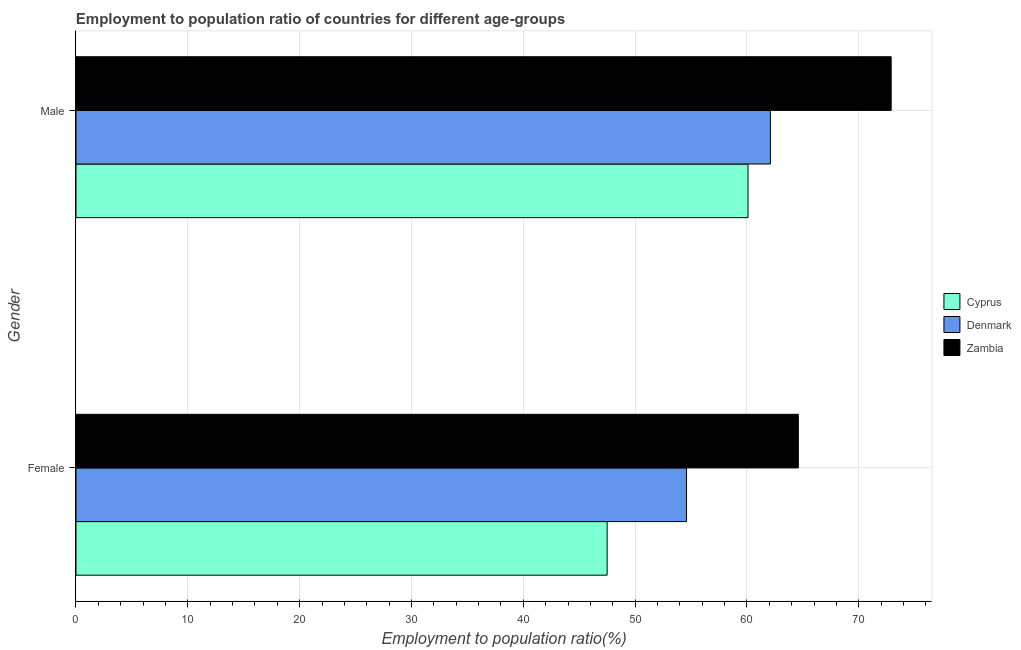How many groups of bars are there?
Provide a succinct answer. 2. How many bars are there on the 2nd tick from the bottom?
Ensure brevity in your answer.  3. What is the employment to population ratio(female) in Zambia?
Make the answer very short. 64.6. Across all countries, what is the maximum employment to population ratio(male)?
Keep it short and to the point. 72.9. Across all countries, what is the minimum employment to population ratio(female)?
Your answer should be very brief. 47.5. In which country was the employment to population ratio(female) maximum?
Give a very brief answer. Zambia. In which country was the employment to population ratio(female) minimum?
Ensure brevity in your answer.  Cyprus. What is the total employment to population ratio(female) in the graph?
Offer a very short reply. 166.7. What is the difference between the employment to population ratio(female) in Zambia and that in Cyprus?
Make the answer very short. 17.1. What is the difference between the employment to population ratio(female) in Cyprus and the employment to population ratio(male) in Denmark?
Provide a succinct answer. -14.6. What is the average employment to population ratio(male) per country?
Give a very brief answer. 65.03. What is the difference between the employment to population ratio(male) and employment to population ratio(female) in Zambia?
Provide a short and direct response. 8.3. In how many countries, is the employment to population ratio(male) greater than 74 %?
Offer a very short reply. 0. What is the ratio of the employment to population ratio(female) in Zambia to that in Denmark?
Your answer should be very brief. 1.18. In how many countries, is the employment to population ratio(female) greater than the average employment to population ratio(female) taken over all countries?
Your answer should be compact. 1. What does the 3rd bar from the top in Male represents?
Your response must be concise. Cyprus. What does the 3rd bar from the bottom in Male represents?
Make the answer very short. Zambia. How many bars are there?
Your answer should be compact. 6. Are all the bars in the graph horizontal?
Provide a short and direct response. Yes. How many countries are there in the graph?
Ensure brevity in your answer.  3. What is the difference between two consecutive major ticks on the X-axis?
Keep it short and to the point. 10. Are the values on the major ticks of X-axis written in scientific E-notation?
Your answer should be compact. No. Does the graph contain grids?
Provide a succinct answer. Yes. How are the legend labels stacked?
Make the answer very short. Vertical. What is the title of the graph?
Ensure brevity in your answer.  Employment to population ratio of countries for different age-groups. What is the label or title of the X-axis?
Provide a succinct answer. Employment to population ratio(%). What is the label or title of the Y-axis?
Offer a terse response. Gender. What is the Employment to population ratio(%) in Cyprus in Female?
Offer a very short reply. 47.5. What is the Employment to population ratio(%) in Denmark in Female?
Your response must be concise. 54.6. What is the Employment to population ratio(%) of Zambia in Female?
Your response must be concise. 64.6. What is the Employment to population ratio(%) in Cyprus in Male?
Offer a very short reply. 60.1. What is the Employment to population ratio(%) in Denmark in Male?
Your answer should be compact. 62.1. What is the Employment to population ratio(%) in Zambia in Male?
Offer a terse response. 72.9. Across all Gender, what is the maximum Employment to population ratio(%) in Cyprus?
Offer a very short reply. 60.1. Across all Gender, what is the maximum Employment to population ratio(%) in Denmark?
Ensure brevity in your answer.  62.1. Across all Gender, what is the maximum Employment to population ratio(%) of Zambia?
Make the answer very short. 72.9. Across all Gender, what is the minimum Employment to population ratio(%) in Cyprus?
Your answer should be very brief. 47.5. Across all Gender, what is the minimum Employment to population ratio(%) in Denmark?
Your answer should be compact. 54.6. Across all Gender, what is the minimum Employment to population ratio(%) in Zambia?
Give a very brief answer. 64.6. What is the total Employment to population ratio(%) of Cyprus in the graph?
Your response must be concise. 107.6. What is the total Employment to population ratio(%) in Denmark in the graph?
Your answer should be very brief. 116.7. What is the total Employment to population ratio(%) in Zambia in the graph?
Ensure brevity in your answer.  137.5. What is the difference between the Employment to population ratio(%) in Denmark in Female and that in Male?
Your answer should be compact. -7.5. What is the difference between the Employment to population ratio(%) in Cyprus in Female and the Employment to population ratio(%) in Denmark in Male?
Offer a very short reply. -14.6. What is the difference between the Employment to population ratio(%) of Cyprus in Female and the Employment to population ratio(%) of Zambia in Male?
Ensure brevity in your answer.  -25.4. What is the difference between the Employment to population ratio(%) of Denmark in Female and the Employment to population ratio(%) of Zambia in Male?
Your answer should be compact. -18.3. What is the average Employment to population ratio(%) in Cyprus per Gender?
Offer a terse response. 53.8. What is the average Employment to population ratio(%) of Denmark per Gender?
Keep it short and to the point. 58.35. What is the average Employment to population ratio(%) of Zambia per Gender?
Make the answer very short. 68.75. What is the difference between the Employment to population ratio(%) of Cyprus and Employment to population ratio(%) of Zambia in Female?
Offer a terse response. -17.1. What is the difference between the Employment to population ratio(%) in Denmark and Employment to population ratio(%) in Zambia in Female?
Your answer should be very brief. -10. What is the difference between the Employment to population ratio(%) of Cyprus and Employment to population ratio(%) of Denmark in Male?
Your answer should be very brief. -2. What is the difference between the Employment to population ratio(%) in Cyprus and Employment to population ratio(%) in Zambia in Male?
Ensure brevity in your answer.  -12.8. What is the difference between the Employment to population ratio(%) in Denmark and Employment to population ratio(%) in Zambia in Male?
Offer a terse response. -10.8. What is the ratio of the Employment to population ratio(%) of Cyprus in Female to that in Male?
Make the answer very short. 0.79. What is the ratio of the Employment to population ratio(%) of Denmark in Female to that in Male?
Your response must be concise. 0.88. What is the ratio of the Employment to population ratio(%) of Zambia in Female to that in Male?
Your answer should be compact. 0.89. What is the difference between the highest and the second highest Employment to population ratio(%) of Cyprus?
Your answer should be compact. 12.6. What is the difference between the highest and the lowest Employment to population ratio(%) in Denmark?
Offer a terse response. 7.5. 